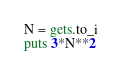Convert code to text. <code><loc_0><loc_0><loc_500><loc_500><_Ruby_>N = gets.to_i
puts 3*N**2</code> 